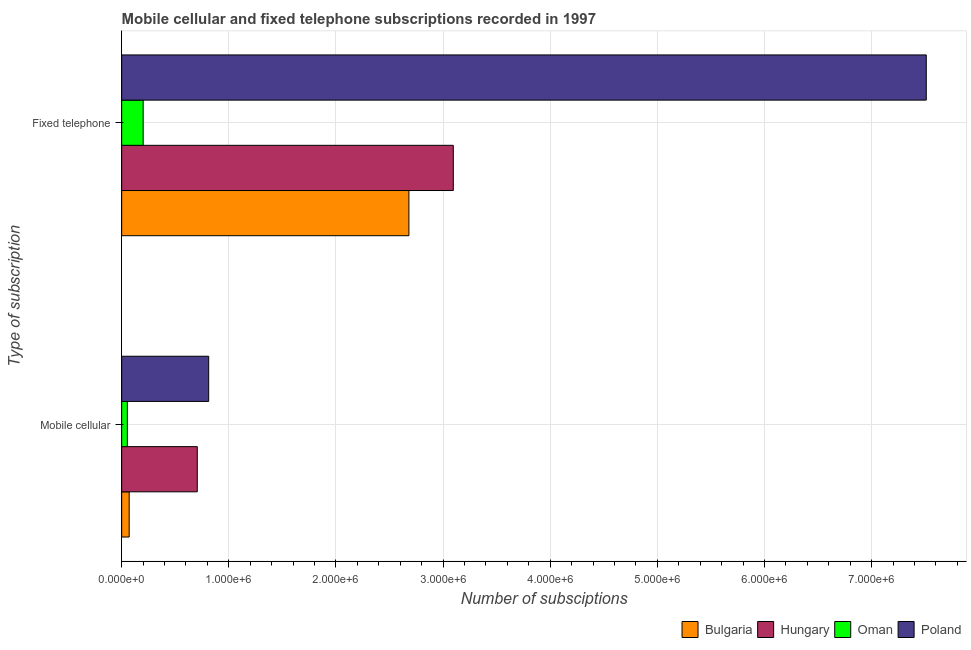How many groups of bars are there?
Ensure brevity in your answer.  2. Are the number of bars on each tick of the Y-axis equal?
Offer a terse response. Yes. What is the label of the 1st group of bars from the top?
Give a very brief answer. Fixed telephone. What is the number of fixed telephone subscriptions in Hungary?
Give a very brief answer. 3.10e+06. Across all countries, what is the maximum number of fixed telephone subscriptions?
Keep it short and to the point. 7.51e+06. Across all countries, what is the minimum number of fixed telephone subscriptions?
Your answer should be very brief. 2.01e+05. In which country was the number of fixed telephone subscriptions maximum?
Provide a succinct answer. Poland. In which country was the number of mobile cellular subscriptions minimum?
Provide a succinct answer. Oman. What is the total number of mobile cellular subscriptions in the graph?
Offer a very short reply. 1.64e+06. What is the difference between the number of fixed telephone subscriptions in Oman and that in Hungary?
Provide a short and direct response. -2.89e+06. What is the difference between the number of fixed telephone subscriptions in Bulgaria and the number of mobile cellular subscriptions in Poland?
Provide a short and direct response. 1.87e+06. What is the average number of mobile cellular subscriptions per country?
Offer a very short reply. 4.10e+05. What is the difference between the number of mobile cellular subscriptions and number of fixed telephone subscriptions in Oman?
Your answer should be very brief. -1.48e+05. In how many countries, is the number of fixed telephone subscriptions greater than 3000000 ?
Keep it short and to the point. 2. What is the ratio of the number of fixed telephone subscriptions in Bulgaria to that in Poland?
Give a very brief answer. 0.36. In how many countries, is the number of fixed telephone subscriptions greater than the average number of fixed telephone subscriptions taken over all countries?
Make the answer very short. 1. What does the 2nd bar from the top in Fixed telephone represents?
Provide a succinct answer. Oman. What does the 1st bar from the bottom in Mobile cellular represents?
Your answer should be compact. Bulgaria. Are all the bars in the graph horizontal?
Make the answer very short. Yes. How many countries are there in the graph?
Offer a terse response. 4. What is the difference between two consecutive major ticks on the X-axis?
Provide a short and direct response. 1.00e+06. Where does the legend appear in the graph?
Make the answer very short. Bottom right. How many legend labels are there?
Offer a terse response. 4. What is the title of the graph?
Offer a terse response. Mobile cellular and fixed telephone subscriptions recorded in 1997. Does "Low income" appear as one of the legend labels in the graph?
Offer a terse response. No. What is the label or title of the X-axis?
Provide a succinct answer. Number of subsciptions. What is the label or title of the Y-axis?
Your answer should be very brief. Type of subscription. What is the Number of subsciptions in Hungary in Mobile cellular?
Provide a succinct answer. 7.06e+05. What is the Number of subsciptions in Oman in Mobile cellular?
Offer a very short reply. 5.30e+04. What is the Number of subsciptions of Poland in Mobile cellular?
Your answer should be very brief. 8.12e+05. What is the Number of subsciptions in Bulgaria in Fixed telephone?
Your answer should be compact. 2.68e+06. What is the Number of subsciptions of Hungary in Fixed telephone?
Provide a succinct answer. 3.10e+06. What is the Number of subsciptions of Oman in Fixed telephone?
Your response must be concise. 2.01e+05. What is the Number of subsciptions in Poland in Fixed telephone?
Provide a succinct answer. 7.51e+06. Across all Type of subscription, what is the maximum Number of subsciptions of Bulgaria?
Provide a succinct answer. 2.68e+06. Across all Type of subscription, what is the maximum Number of subsciptions in Hungary?
Ensure brevity in your answer.  3.10e+06. Across all Type of subscription, what is the maximum Number of subsciptions of Oman?
Offer a terse response. 2.01e+05. Across all Type of subscription, what is the maximum Number of subsciptions in Poland?
Offer a very short reply. 7.51e+06. Across all Type of subscription, what is the minimum Number of subsciptions in Hungary?
Your response must be concise. 7.06e+05. Across all Type of subscription, what is the minimum Number of subsciptions in Oman?
Keep it short and to the point. 5.30e+04. Across all Type of subscription, what is the minimum Number of subsciptions of Poland?
Your response must be concise. 8.12e+05. What is the total Number of subsciptions in Bulgaria in the graph?
Offer a terse response. 2.75e+06. What is the total Number of subsciptions of Hungary in the graph?
Offer a very short reply. 3.80e+06. What is the total Number of subsciptions in Oman in the graph?
Your response must be concise. 2.54e+05. What is the total Number of subsciptions in Poland in the graph?
Provide a succinct answer. 8.32e+06. What is the difference between the Number of subsciptions in Bulgaria in Mobile cellular and that in Fixed telephone?
Provide a short and direct response. -2.61e+06. What is the difference between the Number of subsciptions in Hungary in Mobile cellular and that in Fixed telephone?
Offer a terse response. -2.39e+06. What is the difference between the Number of subsciptions in Oman in Mobile cellular and that in Fixed telephone?
Your answer should be compact. -1.48e+05. What is the difference between the Number of subsciptions of Poland in Mobile cellular and that in Fixed telephone?
Offer a very short reply. -6.70e+06. What is the difference between the Number of subsciptions in Bulgaria in Mobile cellular and the Number of subsciptions in Hungary in Fixed telephone?
Your response must be concise. -3.03e+06. What is the difference between the Number of subsciptions of Bulgaria in Mobile cellular and the Number of subsciptions of Oman in Fixed telephone?
Your answer should be very brief. -1.31e+05. What is the difference between the Number of subsciptions in Bulgaria in Mobile cellular and the Number of subsciptions in Poland in Fixed telephone?
Make the answer very short. -7.44e+06. What is the difference between the Number of subsciptions in Hungary in Mobile cellular and the Number of subsciptions in Oman in Fixed telephone?
Keep it short and to the point. 5.05e+05. What is the difference between the Number of subsciptions of Hungary in Mobile cellular and the Number of subsciptions of Poland in Fixed telephone?
Provide a short and direct response. -6.80e+06. What is the difference between the Number of subsciptions of Oman in Mobile cellular and the Number of subsciptions of Poland in Fixed telephone?
Offer a terse response. -7.46e+06. What is the average Number of subsciptions in Bulgaria per Type of subscription?
Keep it short and to the point. 1.38e+06. What is the average Number of subsciptions in Hungary per Type of subscription?
Offer a very short reply. 1.90e+06. What is the average Number of subsciptions of Oman per Type of subscription?
Make the answer very short. 1.27e+05. What is the average Number of subsciptions in Poland per Type of subscription?
Ensure brevity in your answer.  4.16e+06. What is the difference between the Number of subsciptions of Bulgaria and Number of subsciptions of Hungary in Mobile cellular?
Make the answer very short. -6.36e+05. What is the difference between the Number of subsciptions in Bulgaria and Number of subsciptions in Oman in Mobile cellular?
Make the answer very short. 1.70e+04. What is the difference between the Number of subsciptions of Bulgaria and Number of subsciptions of Poland in Mobile cellular?
Your answer should be very brief. -7.42e+05. What is the difference between the Number of subsciptions of Hungary and Number of subsciptions of Oman in Mobile cellular?
Your response must be concise. 6.53e+05. What is the difference between the Number of subsciptions in Hungary and Number of subsciptions in Poland in Mobile cellular?
Provide a succinct answer. -1.06e+05. What is the difference between the Number of subsciptions in Oman and Number of subsciptions in Poland in Mobile cellular?
Offer a very short reply. -7.59e+05. What is the difference between the Number of subsciptions in Bulgaria and Number of subsciptions in Hungary in Fixed telephone?
Provide a succinct answer. -4.14e+05. What is the difference between the Number of subsciptions of Bulgaria and Number of subsciptions of Oman in Fixed telephone?
Provide a succinct answer. 2.48e+06. What is the difference between the Number of subsciptions of Bulgaria and Number of subsciptions of Poland in Fixed telephone?
Ensure brevity in your answer.  -4.83e+06. What is the difference between the Number of subsciptions in Hungary and Number of subsciptions in Oman in Fixed telephone?
Give a very brief answer. 2.89e+06. What is the difference between the Number of subsciptions in Hungary and Number of subsciptions in Poland in Fixed telephone?
Offer a terse response. -4.41e+06. What is the difference between the Number of subsciptions of Oman and Number of subsciptions of Poland in Fixed telephone?
Provide a succinct answer. -7.31e+06. What is the ratio of the Number of subsciptions of Bulgaria in Mobile cellular to that in Fixed telephone?
Ensure brevity in your answer.  0.03. What is the ratio of the Number of subsciptions in Hungary in Mobile cellular to that in Fixed telephone?
Keep it short and to the point. 0.23. What is the ratio of the Number of subsciptions of Oman in Mobile cellular to that in Fixed telephone?
Provide a short and direct response. 0.26. What is the ratio of the Number of subsciptions in Poland in Mobile cellular to that in Fixed telephone?
Make the answer very short. 0.11. What is the difference between the highest and the second highest Number of subsciptions in Bulgaria?
Offer a very short reply. 2.61e+06. What is the difference between the highest and the second highest Number of subsciptions of Hungary?
Your answer should be compact. 2.39e+06. What is the difference between the highest and the second highest Number of subsciptions in Oman?
Keep it short and to the point. 1.48e+05. What is the difference between the highest and the second highest Number of subsciptions in Poland?
Your answer should be compact. 6.70e+06. What is the difference between the highest and the lowest Number of subsciptions in Bulgaria?
Give a very brief answer. 2.61e+06. What is the difference between the highest and the lowest Number of subsciptions in Hungary?
Your answer should be compact. 2.39e+06. What is the difference between the highest and the lowest Number of subsciptions of Oman?
Provide a short and direct response. 1.48e+05. What is the difference between the highest and the lowest Number of subsciptions of Poland?
Provide a succinct answer. 6.70e+06. 